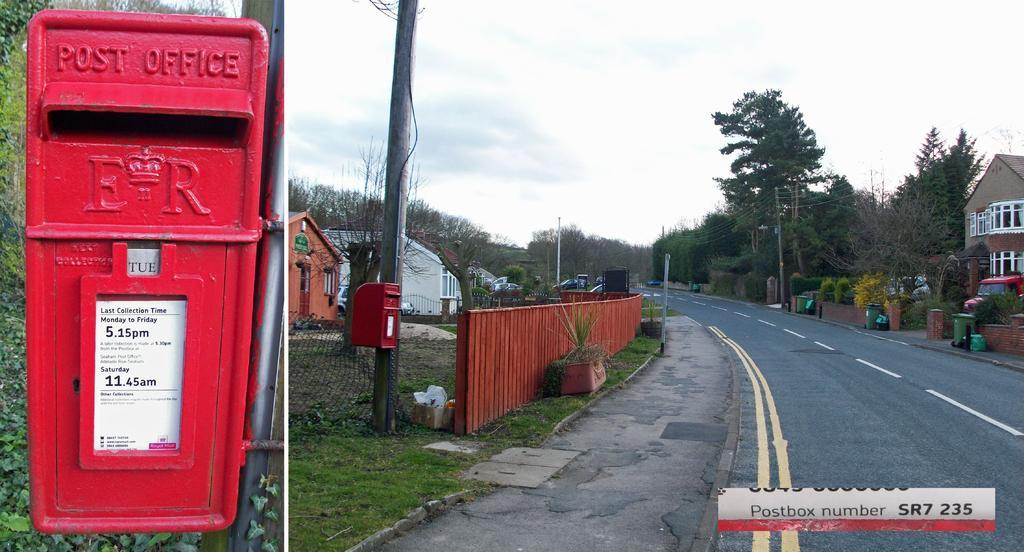Describe this image in one or two sentences. On the left side there is a pole. On that there is a letterbox. Near to that there is another pole with letterbox. Also there is a wooden fencing. Near to that there is a pot with plants. There are grasses on the ground. In the back there are buildings, trees. Also there is a sidewalk and a road. On the right side there is a building, trees, fencing, dustbins. And a vehicle is in front of the building. There is a watermark on the right corner. In the background there is sky. 